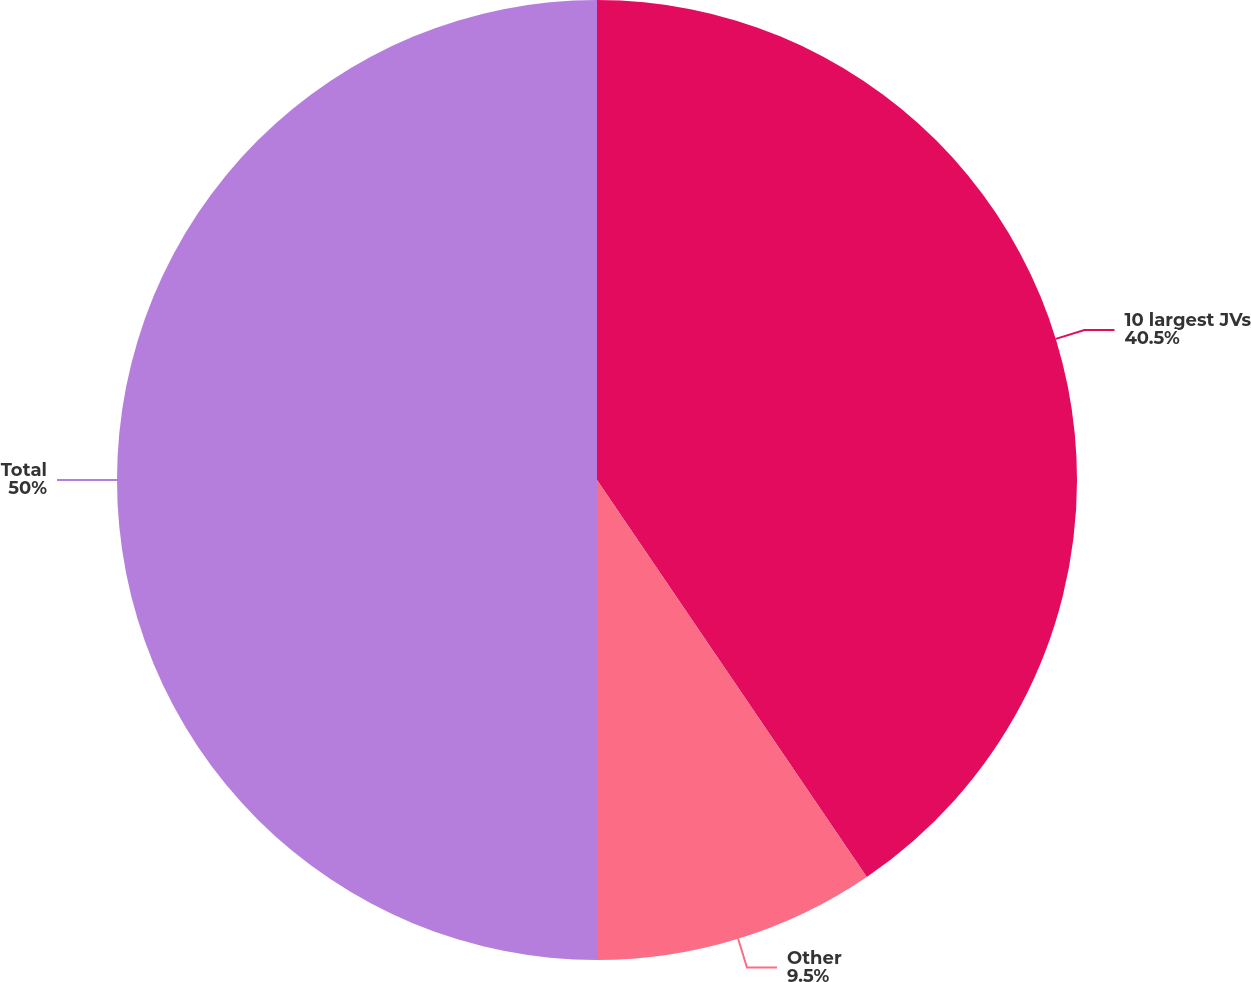Convert chart. <chart><loc_0><loc_0><loc_500><loc_500><pie_chart><fcel>10 largest JVs<fcel>Other<fcel>Total<nl><fcel>40.5%<fcel>9.5%<fcel>50.0%<nl></chart> 